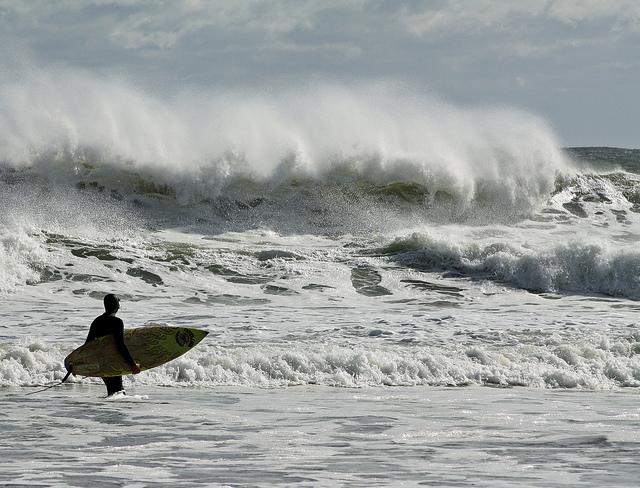Will the wave in this scene crash into the person?
Answer briefly. Yes. How many people are in the water?
Write a very short answer. 1. Is the person walking in water?
Concise answer only. Yes. 